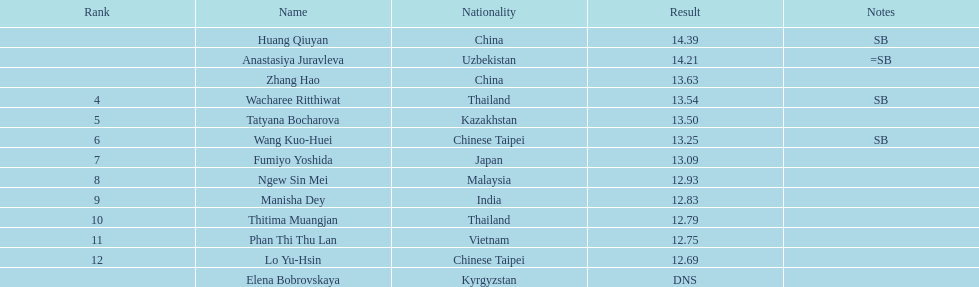What was the average result of the top three jumpers? 14.08. 